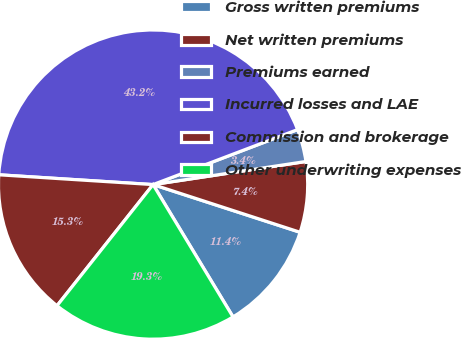Convert chart. <chart><loc_0><loc_0><loc_500><loc_500><pie_chart><fcel>Gross written premiums<fcel>Net written premiums<fcel>Premiums earned<fcel>Incurred losses and LAE<fcel>Commission and brokerage<fcel>Other underwriting expenses<nl><fcel>11.36%<fcel>7.38%<fcel>3.4%<fcel>43.21%<fcel>15.34%<fcel>19.32%<nl></chart> 